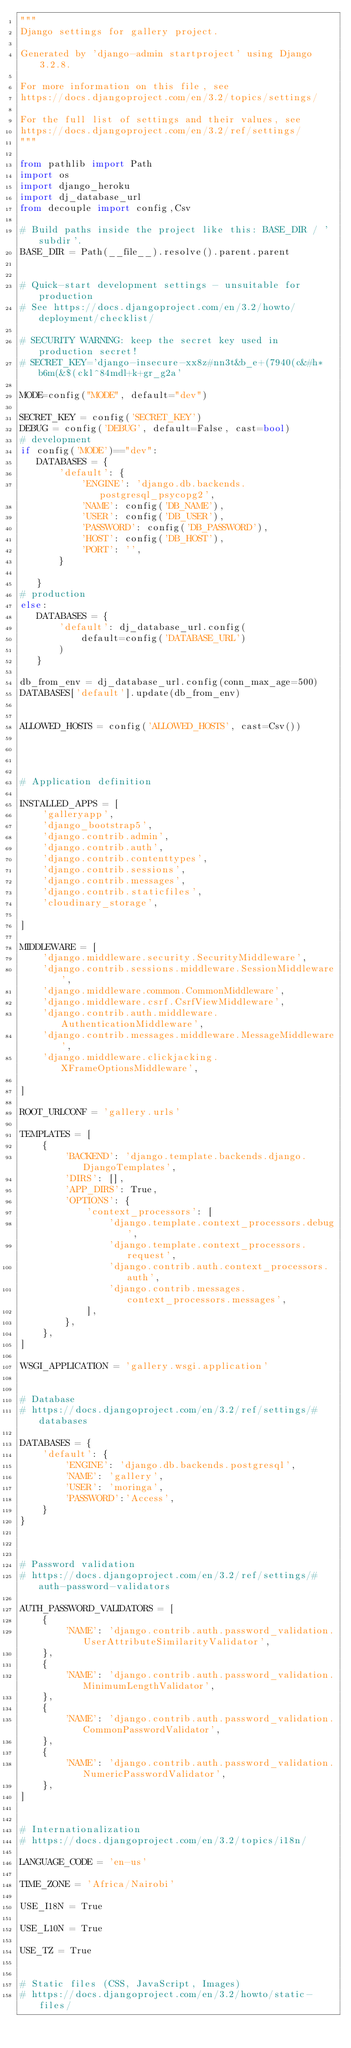Convert code to text. <code><loc_0><loc_0><loc_500><loc_500><_Python_>"""
Django settings for gallery project.

Generated by 'django-admin startproject' using Django 3.2.8.

For more information on this file, see
https://docs.djangoproject.com/en/3.2/topics/settings/

For the full list of settings and their values, see
https://docs.djangoproject.com/en/3.2/ref/settings/
"""

from pathlib import Path
import os
import django_heroku
import dj_database_url
from decouple import config,Csv

# Build paths inside the project like this: BASE_DIR / 'subdir'.
BASE_DIR = Path(__file__).resolve().parent.parent


# Quick-start development settings - unsuitable for production
# See https://docs.djangoproject.com/en/3.2/howto/deployment/checklist/

# SECURITY WARNING: keep the secret key used in production secret!
# SECRET_KEY='django-insecure-xx8z#nn3t&b_e+(7940(c&#h*b6m(&$(ckl^84mdl+k+gr_g2a'

MODE=config("MODE", default="dev")

SECRET_KEY = config('SECRET_KEY')
DEBUG = config('DEBUG', default=False, cast=bool)
# development
if config('MODE')=="dev":
   DATABASES = {
       'default': {
           'ENGINE': 'django.db.backends.postgresql_psycopg2',
           'NAME': config('DB_NAME'),
           'USER': config('DB_USER'),
           'PASSWORD': config('DB_PASSWORD'),
           'HOST': config('DB_HOST'),
           'PORT': '',
       }
       
   }
# production
else:
   DATABASES = {
       'default': dj_database_url.config(
           default=config('DATABASE_URL')
       )
   }

db_from_env = dj_database_url.config(conn_max_age=500)
DATABASES['default'].update(db_from_env)


ALLOWED_HOSTS = config('ALLOWED_HOSTS', cast=Csv())




# Application definition

INSTALLED_APPS = [
    'galleryapp',
    'django_bootstrap5',
    'django.contrib.admin',
    'django.contrib.auth',
    'django.contrib.contenttypes',
    'django.contrib.sessions',
    'django.contrib.messages',
    'django.contrib.staticfiles',
    'cloudinary_storage',

]

MIDDLEWARE = [
    'django.middleware.security.SecurityMiddleware',
    'django.contrib.sessions.middleware.SessionMiddleware',
    'django.middleware.common.CommonMiddleware',
    'django.middleware.csrf.CsrfViewMiddleware',
    'django.contrib.auth.middleware.AuthenticationMiddleware',
    'django.contrib.messages.middleware.MessageMiddleware',
    'django.middleware.clickjacking.XFrameOptionsMiddleware',

]

ROOT_URLCONF = 'gallery.urls'

TEMPLATES = [
    {
        'BACKEND': 'django.template.backends.django.DjangoTemplates',
        'DIRS': [],
        'APP_DIRS': True,
        'OPTIONS': {
            'context_processors': [
                'django.template.context_processors.debug',
                'django.template.context_processors.request',
                'django.contrib.auth.context_processors.auth',
                'django.contrib.messages.context_processors.messages',
            ],
        },
    },
]

WSGI_APPLICATION = 'gallery.wsgi.application'


# Database
# https://docs.djangoproject.com/en/3.2/ref/settings/#databases

DATABASES = {
    'default': {
        'ENGINE': 'django.db.backends.postgresql',
        'NAME': 'gallery',
        'USER': 'moringa',
        'PASSWORD':'Access',
    }
}



# Password validation
# https://docs.djangoproject.com/en/3.2/ref/settings/#auth-password-validators

AUTH_PASSWORD_VALIDATORS = [
    {
        'NAME': 'django.contrib.auth.password_validation.UserAttributeSimilarityValidator',
    },
    {
        'NAME': 'django.contrib.auth.password_validation.MinimumLengthValidator',
    },
    {
        'NAME': 'django.contrib.auth.password_validation.CommonPasswordValidator',
    },
    {
        'NAME': 'django.contrib.auth.password_validation.NumericPasswordValidator',
    },
]


# Internationalization
# https://docs.djangoproject.com/en/3.2/topics/i18n/

LANGUAGE_CODE = 'en-us'

TIME_ZONE = 'Africa/Nairobi'

USE_I18N = True

USE_L10N = True

USE_TZ = True


# Static files (CSS, JavaScript, Images)
# https://docs.djangoproject.com/en/3.2/howto/static-files/
</code> 